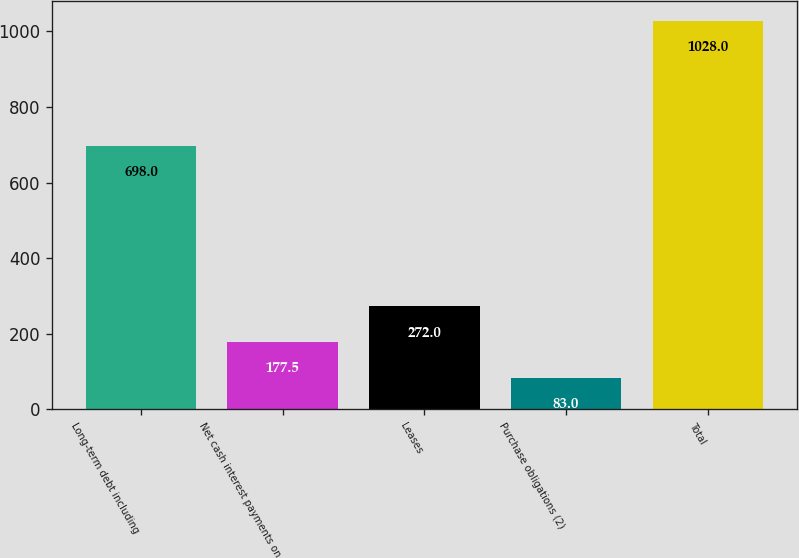Convert chart to OTSL. <chart><loc_0><loc_0><loc_500><loc_500><bar_chart><fcel>Long-term debt including<fcel>Net cash interest payments on<fcel>Leases<fcel>Purchase obligations (2)<fcel>Total<nl><fcel>698<fcel>177.5<fcel>272<fcel>83<fcel>1028<nl></chart> 